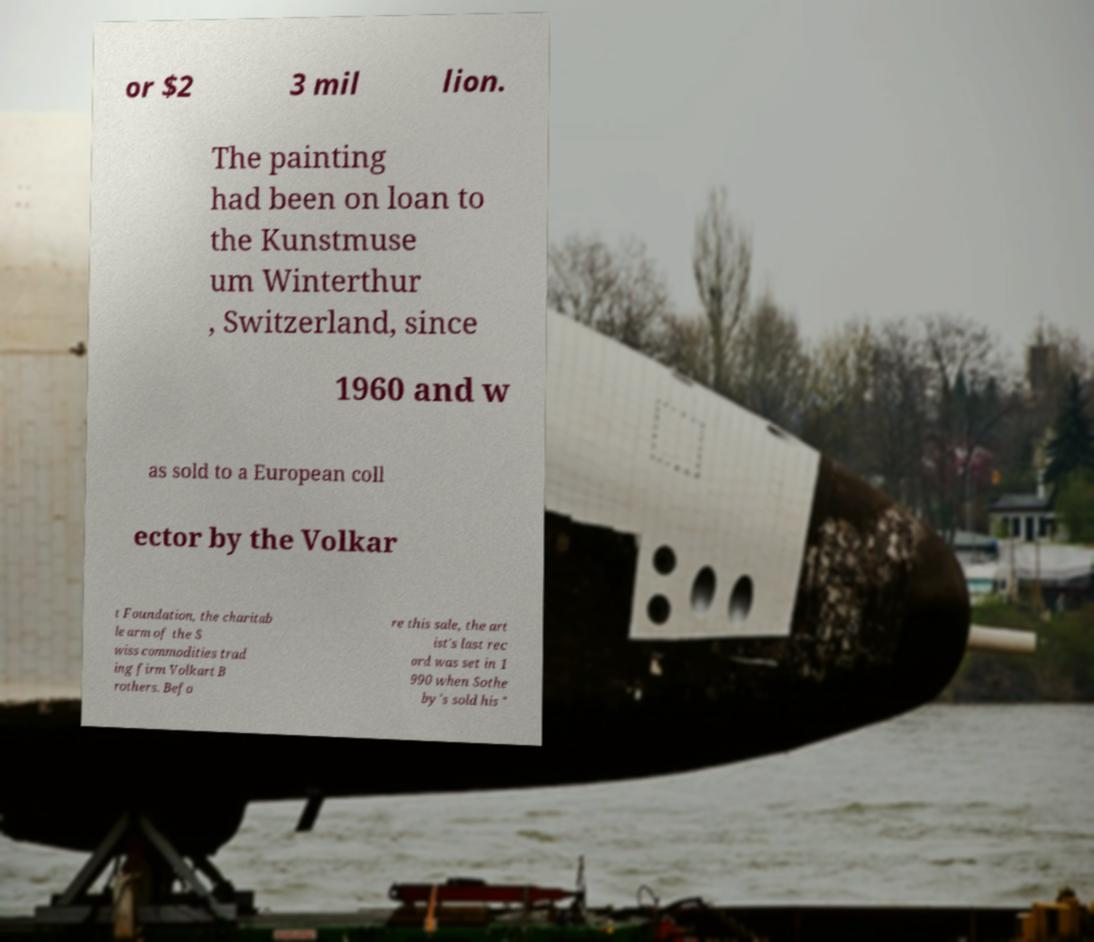Please read and relay the text visible in this image. What does it say? or $2 3 mil lion. The painting had been on loan to the Kunstmuse um Winterthur , Switzerland, since 1960 and w as sold to a European coll ector by the Volkar t Foundation, the charitab le arm of the S wiss commodities trad ing firm Volkart B rothers. Befo re this sale, the art ist's last rec ord was set in 1 990 when Sothe by's sold his " 